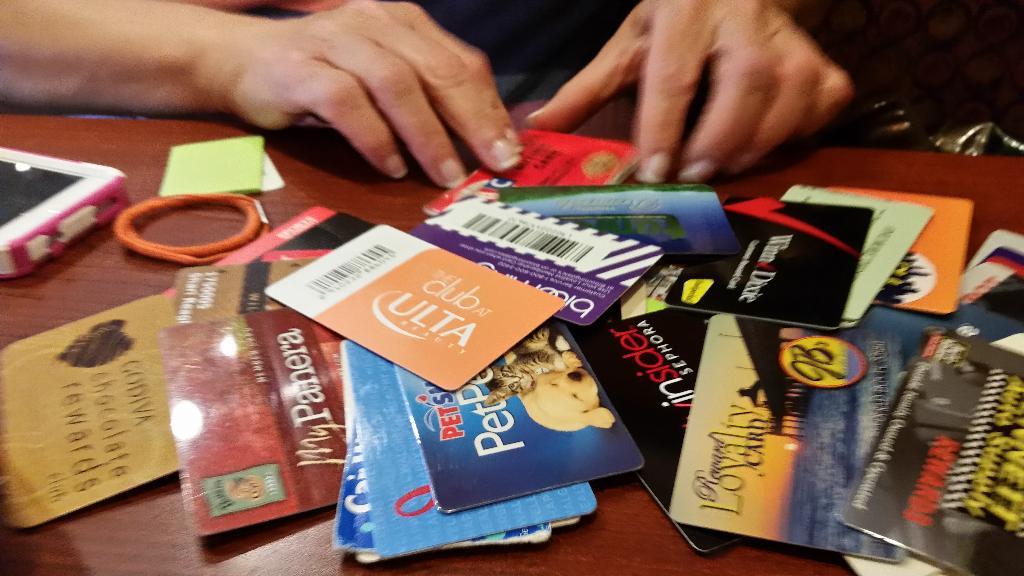What brand is the orange card?
Offer a terse response. Ulta. 